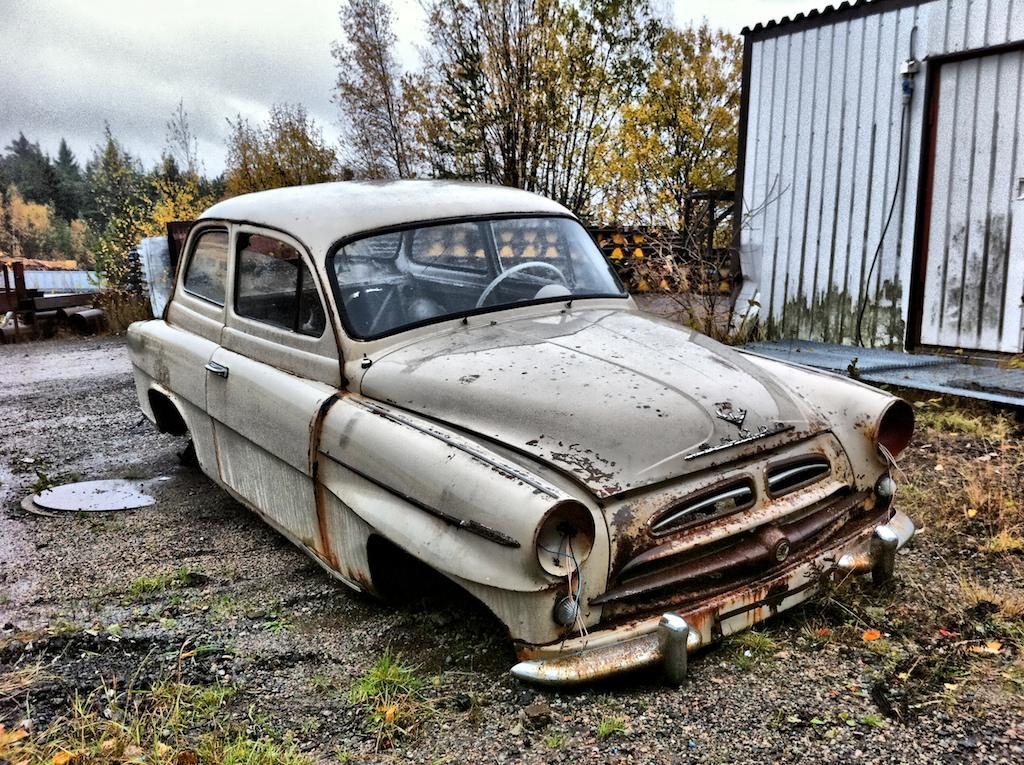What is the main subject of the image? The main subject of the image is a car. What can be seen on the right side of the image? There is an iron sheet shed on the right side of the image. What type of vegetation is visible in the background of the image? There are trees in the background of the image. How would you describe the sky in the image? The sky is cloudy in the background of the image. What type of grain is being harvested by the squirrel in the image? There is no squirrel or grain present in the image. What musical instrument is being played by the person in the image? There is no person or musical instrument present in the image. 